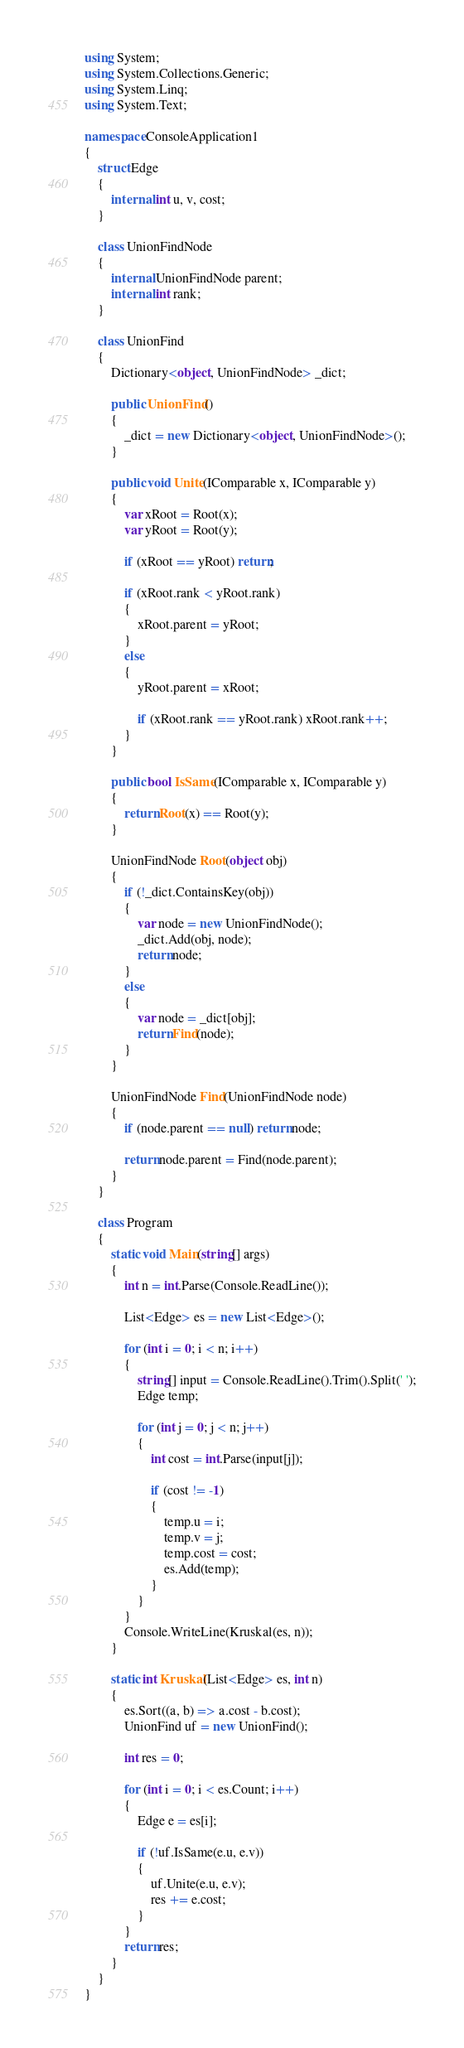Convert code to text. <code><loc_0><loc_0><loc_500><loc_500><_C#_>using System;
using System.Collections.Generic;
using System.Linq;
using System.Text;

namespace ConsoleApplication1
{
    struct Edge
    {
        internal int u, v, cost;
    }

    class UnionFindNode
    {
        internal UnionFindNode parent;
        internal int rank;
    }

    class UnionFind
    {
        Dictionary<object, UnionFindNode> _dict;

        public UnionFind()
        {
            _dict = new Dictionary<object, UnionFindNode>();
        }

        public void Unite(IComparable x, IComparable y)
        {
            var xRoot = Root(x);
            var yRoot = Root(y);

            if (xRoot == yRoot) return;

            if (xRoot.rank < yRoot.rank)
            {
                xRoot.parent = yRoot;
            }
            else
            {
                yRoot.parent = xRoot;

                if (xRoot.rank == yRoot.rank) xRoot.rank++;
            }
        }

        public bool IsSame(IComparable x, IComparable y)
        {
            return Root(x) == Root(y);
        }

        UnionFindNode Root(object obj)
        {
            if (!_dict.ContainsKey(obj))
            {
                var node = new UnionFindNode();
                _dict.Add(obj, node);
                return node;
            }
            else
            {
                var node = _dict[obj];
                return Find(node);
            }
        }

        UnionFindNode Find(UnionFindNode node)
        {
            if (node.parent == null) return node;

            return node.parent = Find(node.parent);
        }
    }

    class Program
    {
        static void Main(string[] args)
        {
            int n = int.Parse(Console.ReadLine());

            List<Edge> es = new List<Edge>();

            for (int i = 0; i < n; i++)
            {
                string[] input = Console.ReadLine().Trim().Split(' ');
                Edge temp;

                for (int j = 0; j < n; j++)
                {
                    int cost = int.Parse(input[j]);

                    if (cost != -1)
                    {
                        temp.u = i;
                        temp.v = j;
                        temp.cost = cost;
                        es.Add(temp);
                    }
                }
            }
            Console.WriteLine(Kruskal(es, n));
        }

        static int Kruskal(List<Edge> es, int n)
        {
            es.Sort((a, b) => a.cost - b.cost);
            UnionFind uf = new UnionFind();

            int res = 0;

            for (int i = 0; i < es.Count; i++)
            {
                Edge e = es[i];

                if (!uf.IsSame(e.u, e.v))
                {
                    uf.Unite(e.u, e.v);
                    res += e.cost;
                }
            }
            return res;
        }
    }
}</code> 